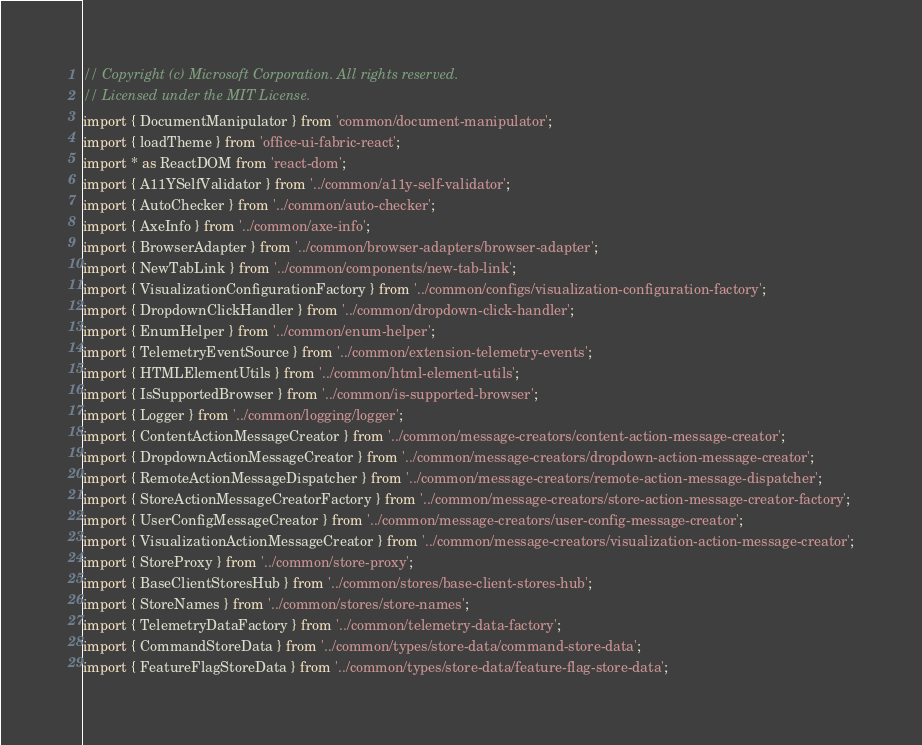<code> <loc_0><loc_0><loc_500><loc_500><_TypeScript_>// Copyright (c) Microsoft Corporation. All rights reserved.
// Licensed under the MIT License.
import { DocumentManipulator } from 'common/document-manipulator';
import { loadTheme } from 'office-ui-fabric-react';
import * as ReactDOM from 'react-dom';
import { A11YSelfValidator } from '../common/a11y-self-validator';
import { AutoChecker } from '../common/auto-checker';
import { AxeInfo } from '../common/axe-info';
import { BrowserAdapter } from '../common/browser-adapters/browser-adapter';
import { NewTabLink } from '../common/components/new-tab-link';
import { VisualizationConfigurationFactory } from '../common/configs/visualization-configuration-factory';
import { DropdownClickHandler } from '../common/dropdown-click-handler';
import { EnumHelper } from '../common/enum-helper';
import { TelemetryEventSource } from '../common/extension-telemetry-events';
import { HTMLElementUtils } from '../common/html-element-utils';
import { IsSupportedBrowser } from '../common/is-supported-browser';
import { Logger } from '../common/logging/logger';
import { ContentActionMessageCreator } from '../common/message-creators/content-action-message-creator';
import { DropdownActionMessageCreator } from '../common/message-creators/dropdown-action-message-creator';
import { RemoteActionMessageDispatcher } from '../common/message-creators/remote-action-message-dispatcher';
import { StoreActionMessageCreatorFactory } from '../common/message-creators/store-action-message-creator-factory';
import { UserConfigMessageCreator } from '../common/message-creators/user-config-message-creator';
import { VisualizationActionMessageCreator } from '../common/message-creators/visualization-action-message-creator';
import { StoreProxy } from '../common/store-proxy';
import { BaseClientStoresHub } from '../common/stores/base-client-stores-hub';
import { StoreNames } from '../common/stores/store-names';
import { TelemetryDataFactory } from '../common/telemetry-data-factory';
import { CommandStoreData } from '../common/types/store-data/command-store-data';
import { FeatureFlagStoreData } from '../common/types/store-data/feature-flag-store-data';</code> 